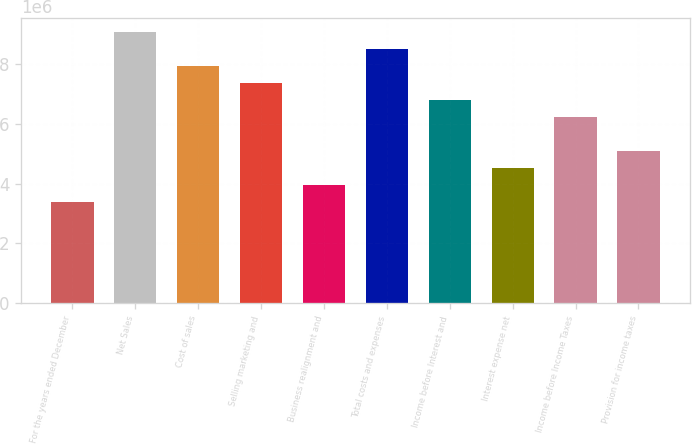Convert chart. <chart><loc_0><loc_0><loc_500><loc_500><bar_chart><fcel>For the years ended December<fcel>Net Sales<fcel>Cost of sales<fcel>Selling marketing and<fcel>Business realignment and<fcel>Total costs and expenses<fcel>Income before Interest and<fcel>Interest expense net<fcel>Income before Income Taxes<fcel>Provision for income taxes<nl><fcel>3.40261e+06<fcel>9.07361e+06<fcel>7.93941e+06<fcel>7.37231e+06<fcel>3.96971e+06<fcel>8.50651e+06<fcel>6.80521e+06<fcel>4.53681e+06<fcel>6.23811e+06<fcel>5.10391e+06<nl></chart> 